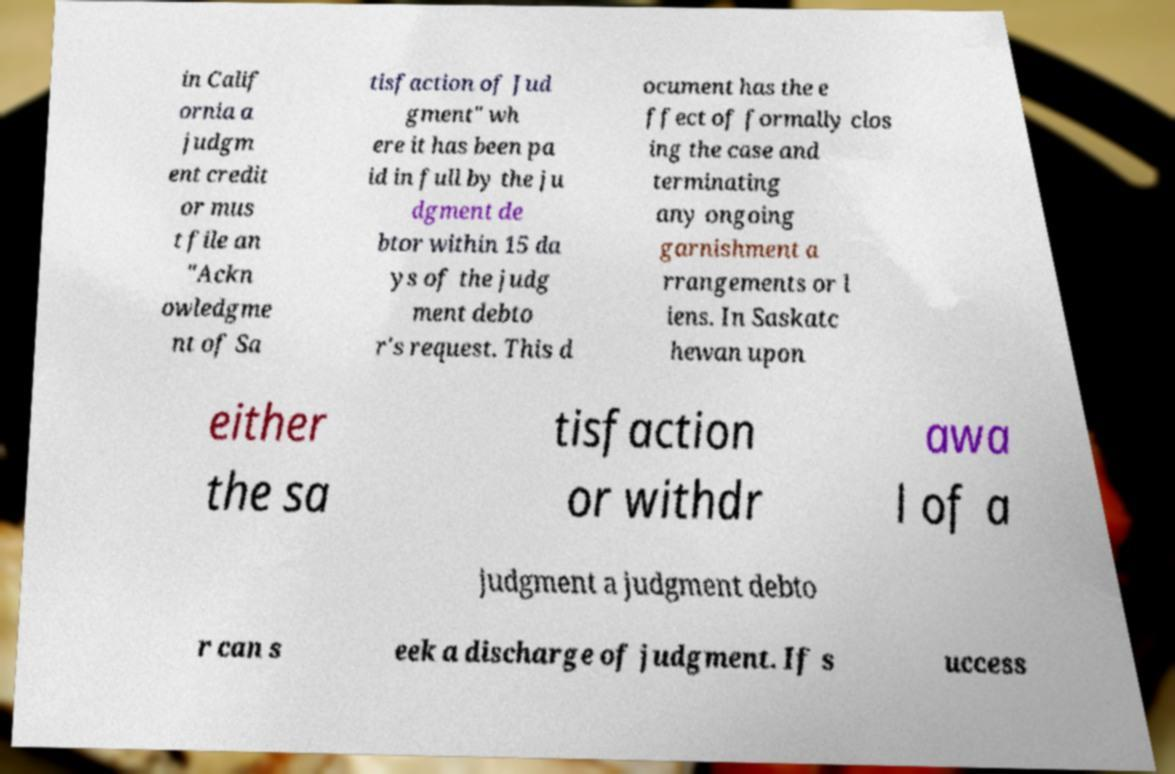For documentation purposes, I need the text within this image transcribed. Could you provide that? in Calif ornia a judgm ent credit or mus t file an "Ackn owledgme nt of Sa tisfaction of Jud gment" wh ere it has been pa id in full by the ju dgment de btor within 15 da ys of the judg ment debto r's request. This d ocument has the e ffect of formally clos ing the case and terminating any ongoing garnishment a rrangements or l iens. In Saskatc hewan upon either the sa tisfaction or withdr awa l of a judgment a judgment debto r can s eek a discharge of judgment. If s uccess 